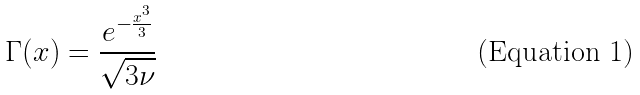Convert formula to latex. <formula><loc_0><loc_0><loc_500><loc_500>\Gamma ( x ) = \frac { e ^ { - \frac { x ^ { 3 } } { 3 } } } { \sqrt { 3 \nu } }</formula> 